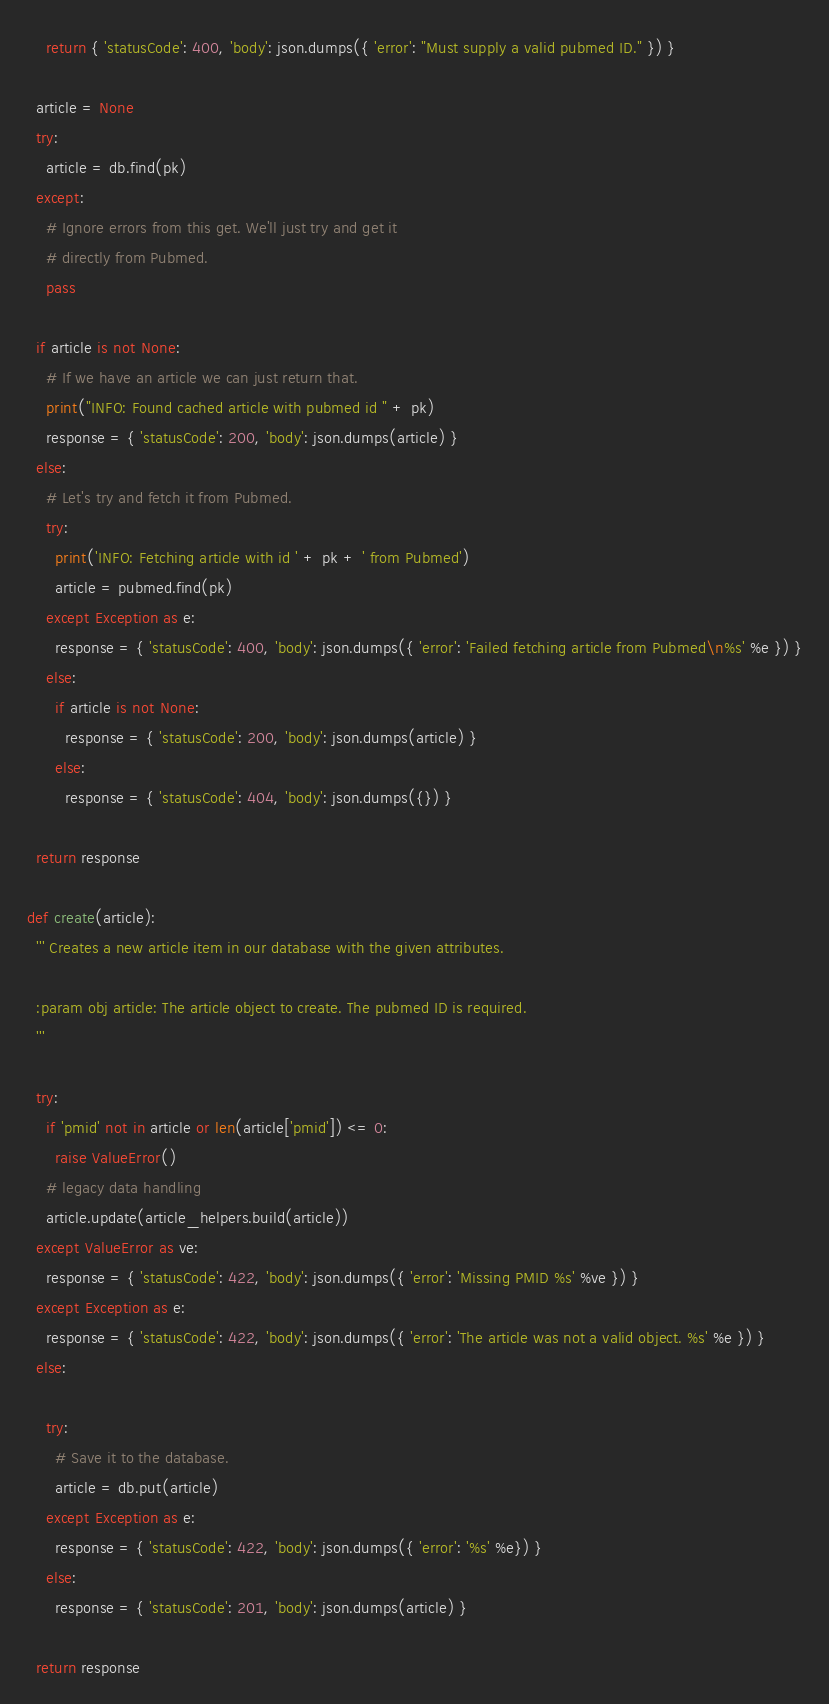Convert code to text. <code><loc_0><loc_0><loc_500><loc_500><_Python_>    return { 'statusCode': 400, 'body': json.dumps({ 'error': "Must supply a valid pubmed ID." }) }

  article = None
  try:
    article = db.find(pk)
  except:
    # Ignore errors from this get. We'll just try and get it
    # directly from Pubmed.
    pass

  if article is not None:
    # If we have an article we can just return that.
    print("INFO: Found cached article with pubmed id " + pk)
    response = { 'statusCode': 200, 'body': json.dumps(article) }
  else:
    # Let's try and fetch it from Pubmed.
    try:
      print('INFO: Fetching article with id ' + pk + ' from Pubmed')
      article = pubmed.find(pk)
    except Exception as e:
      response = { 'statusCode': 400, 'body': json.dumps({ 'error': 'Failed fetching article from Pubmed\n%s' %e }) }
    else:
      if article is not None:
        response = { 'statusCode': 200, 'body': json.dumps(article) }
      else:
        response = { 'statusCode': 404, 'body': json.dumps({}) }

  return response

def create(article):
  ''' Creates a new article item in our database with the given attributes.

  :param obj article: The article object to create. The pubmed ID is required.
  '''

  try:
    if 'pmid' not in article or len(article['pmid']) <= 0:
      raise ValueError()
    # legacy data handling
    article.update(article_helpers.build(article))
  except ValueError as ve:
    response = { 'statusCode': 422, 'body': json.dumps({ 'error': 'Missing PMID %s' %ve }) }
  except Exception as e:
    response = { 'statusCode': 422, 'body': json.dumps({ 'error': 'The article was not a valid object. %s' %e }) }
  else:

    try:
      # Save it to the database.
      article = db.put(article)
    except Exception as e:
      response = { 'statusCode': 422, 'body': json.dumps({ 'error': '%s' %e}) }
    else:
      response = { 'statusCode': 201, 'body': json.dumps(article) }

  return response</code> 